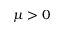Convert formula to latex. <formula><loc_0><loc_0><loc_500><loc_500>\mu > 0</formula> 